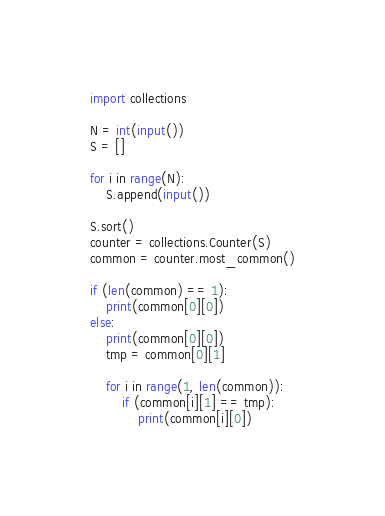<code> <loc_0><loc_0><loc_500><loc_500><_Python_>import collections

N = int(input())
S = []

for i in range(N):
    S.append(input())

S.sort()
counter = collections.Counter(S)
common = counter.most_common()

if (len(common) == 1):
    print(common[0][0])
else:
    print(common[0][0])
    tmp = common[0][1]

    for i in range(1, len(common)):
        if (common[i][1] == tmp):
            print(common[i][0])

</code> 